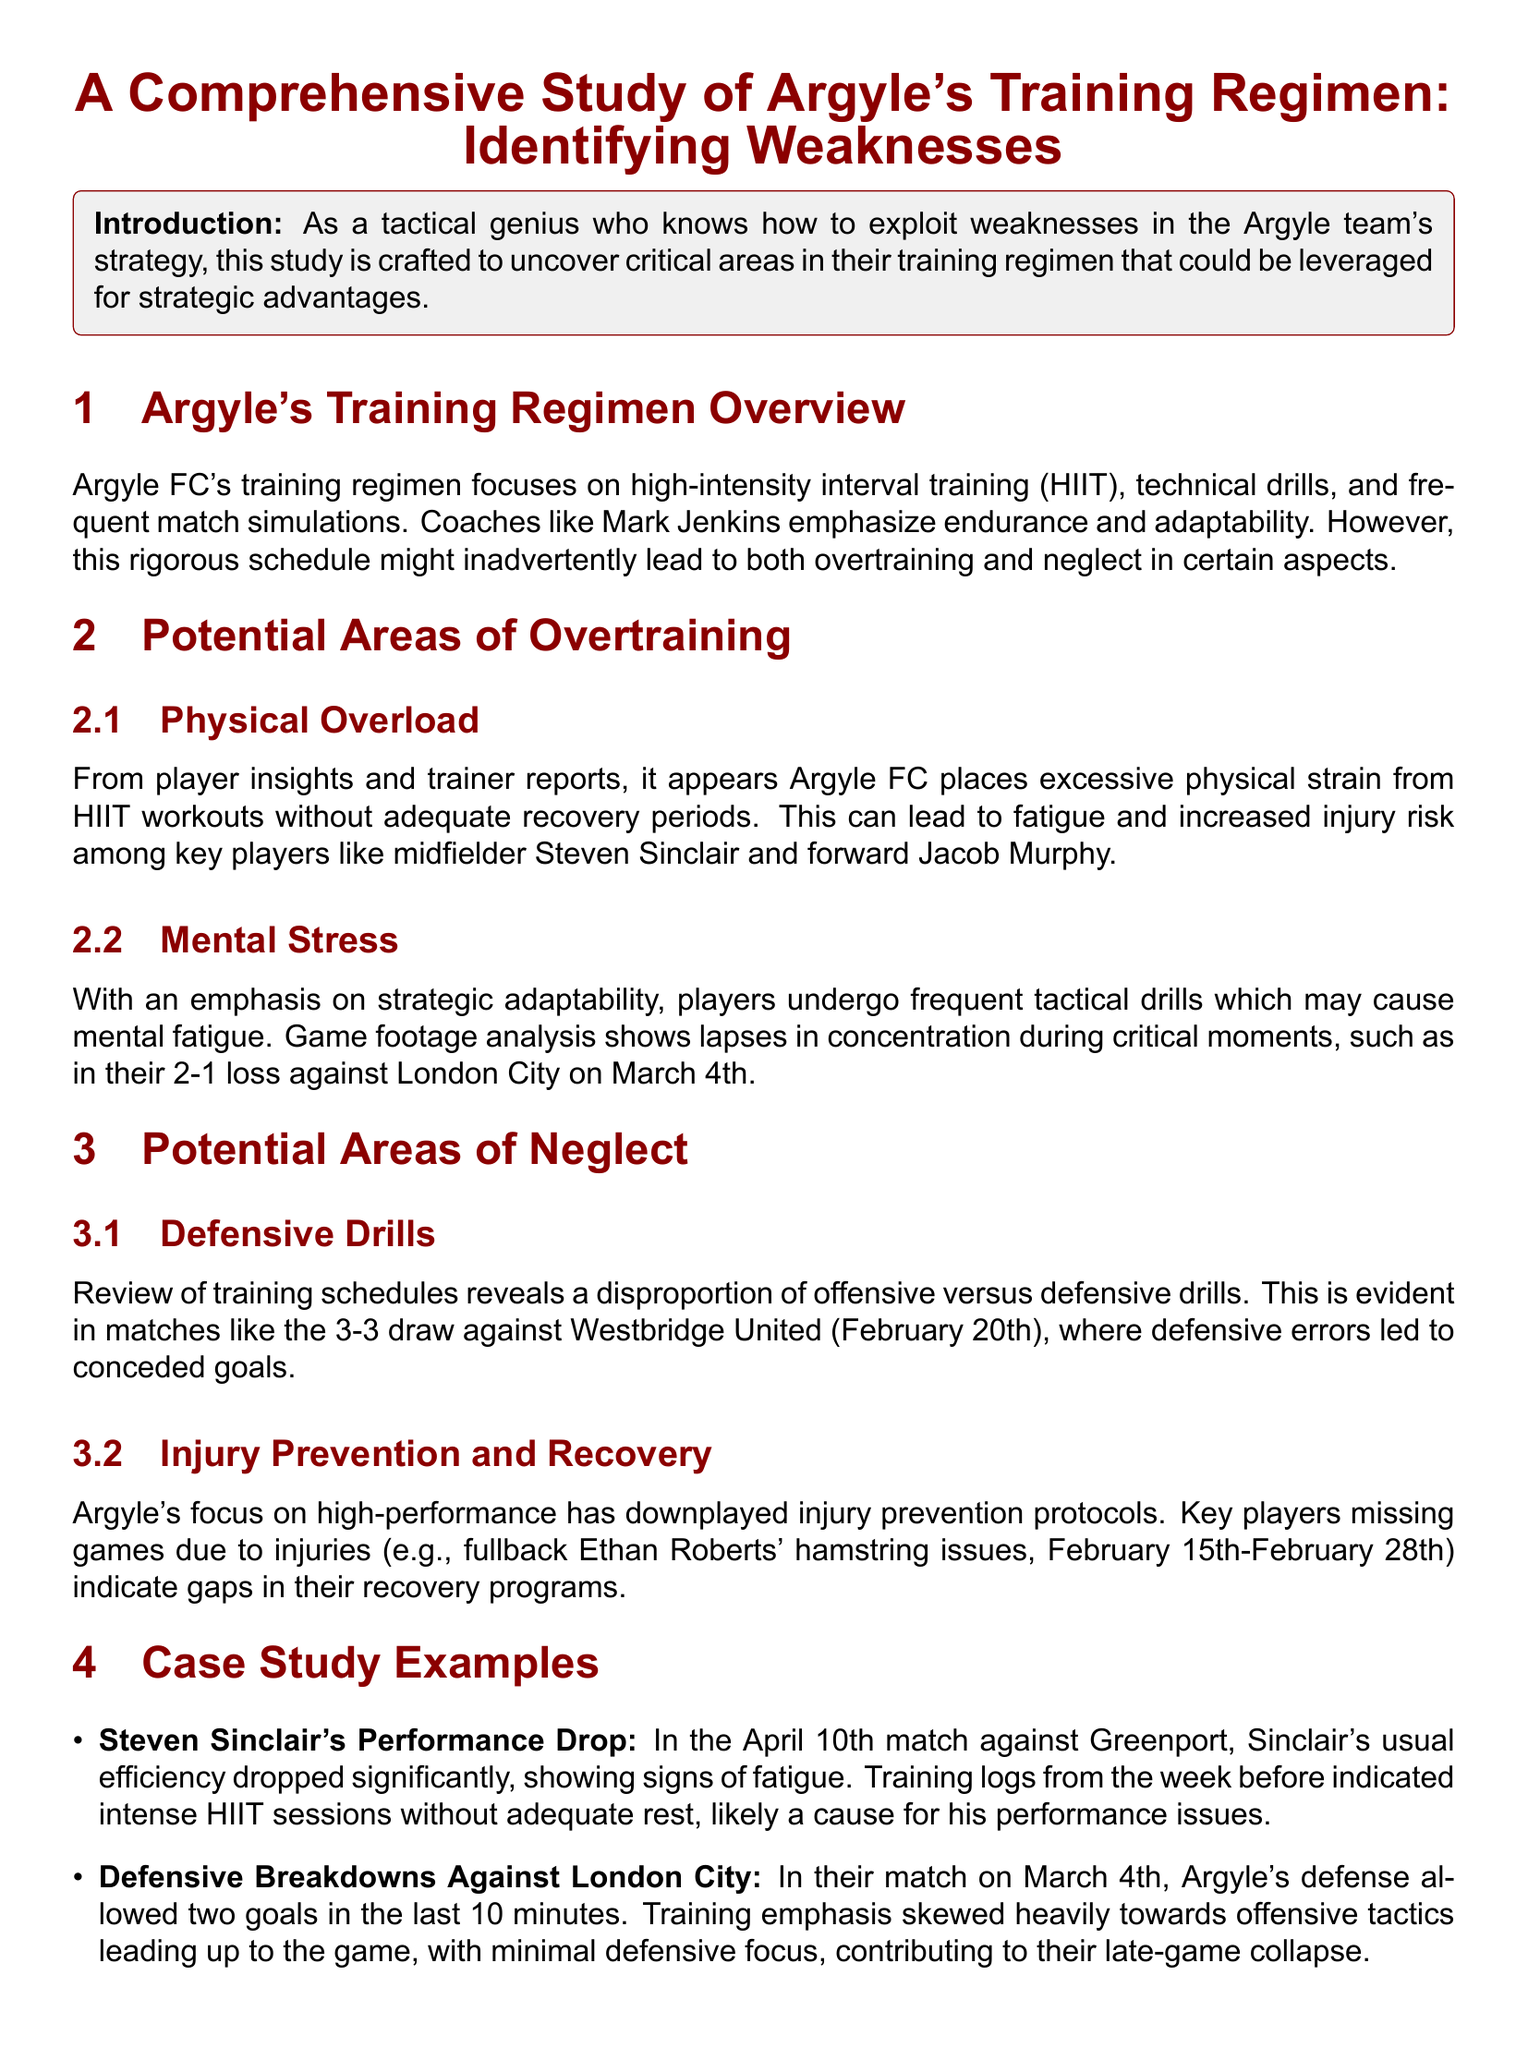What training method is emphasized? The training regimen primarily focuses on high-intensity interval training (HIIT).
Answer: HIIT Who experienced a performance drop in the match against Greenport? The case study mentions Steven Sinclair specifically having a performance drop.
Answer: Steven Sinclair What date did Argyle lose to London City? The document specifies the loss occurred on March 4th.
Answer: March 4th Which player had hamstring issues affecting game participation? The case study notes fullback Ethan Roberts suffered from hamstring issues.
Answer: Ethan Roberts What was a significant consequence of the overtraining noted? Players experienced increased fatigue and risk of injuries, especially in key players.
Answer: Fatigue What trend was noted regarding offensive vs. defensive drills? The training schedules showed a disproportion of offensive versus defensive drills.
Answer: Disproportion In what game did Argyle concede two goals in the last 10 minutes? The document highlights this event occurring during the match against London City.
Answer: London City What does the document suggest for exploiting Argyle's weaknesses? The recommendations include focusing attacks on late-game periods and exploiting defensive lapses.
Answer: Attack late-game Which training element was downplayed according to the study? Injury prevention protocols were identified as being downplayed in the training regimen.
Answer: Injury prevention 